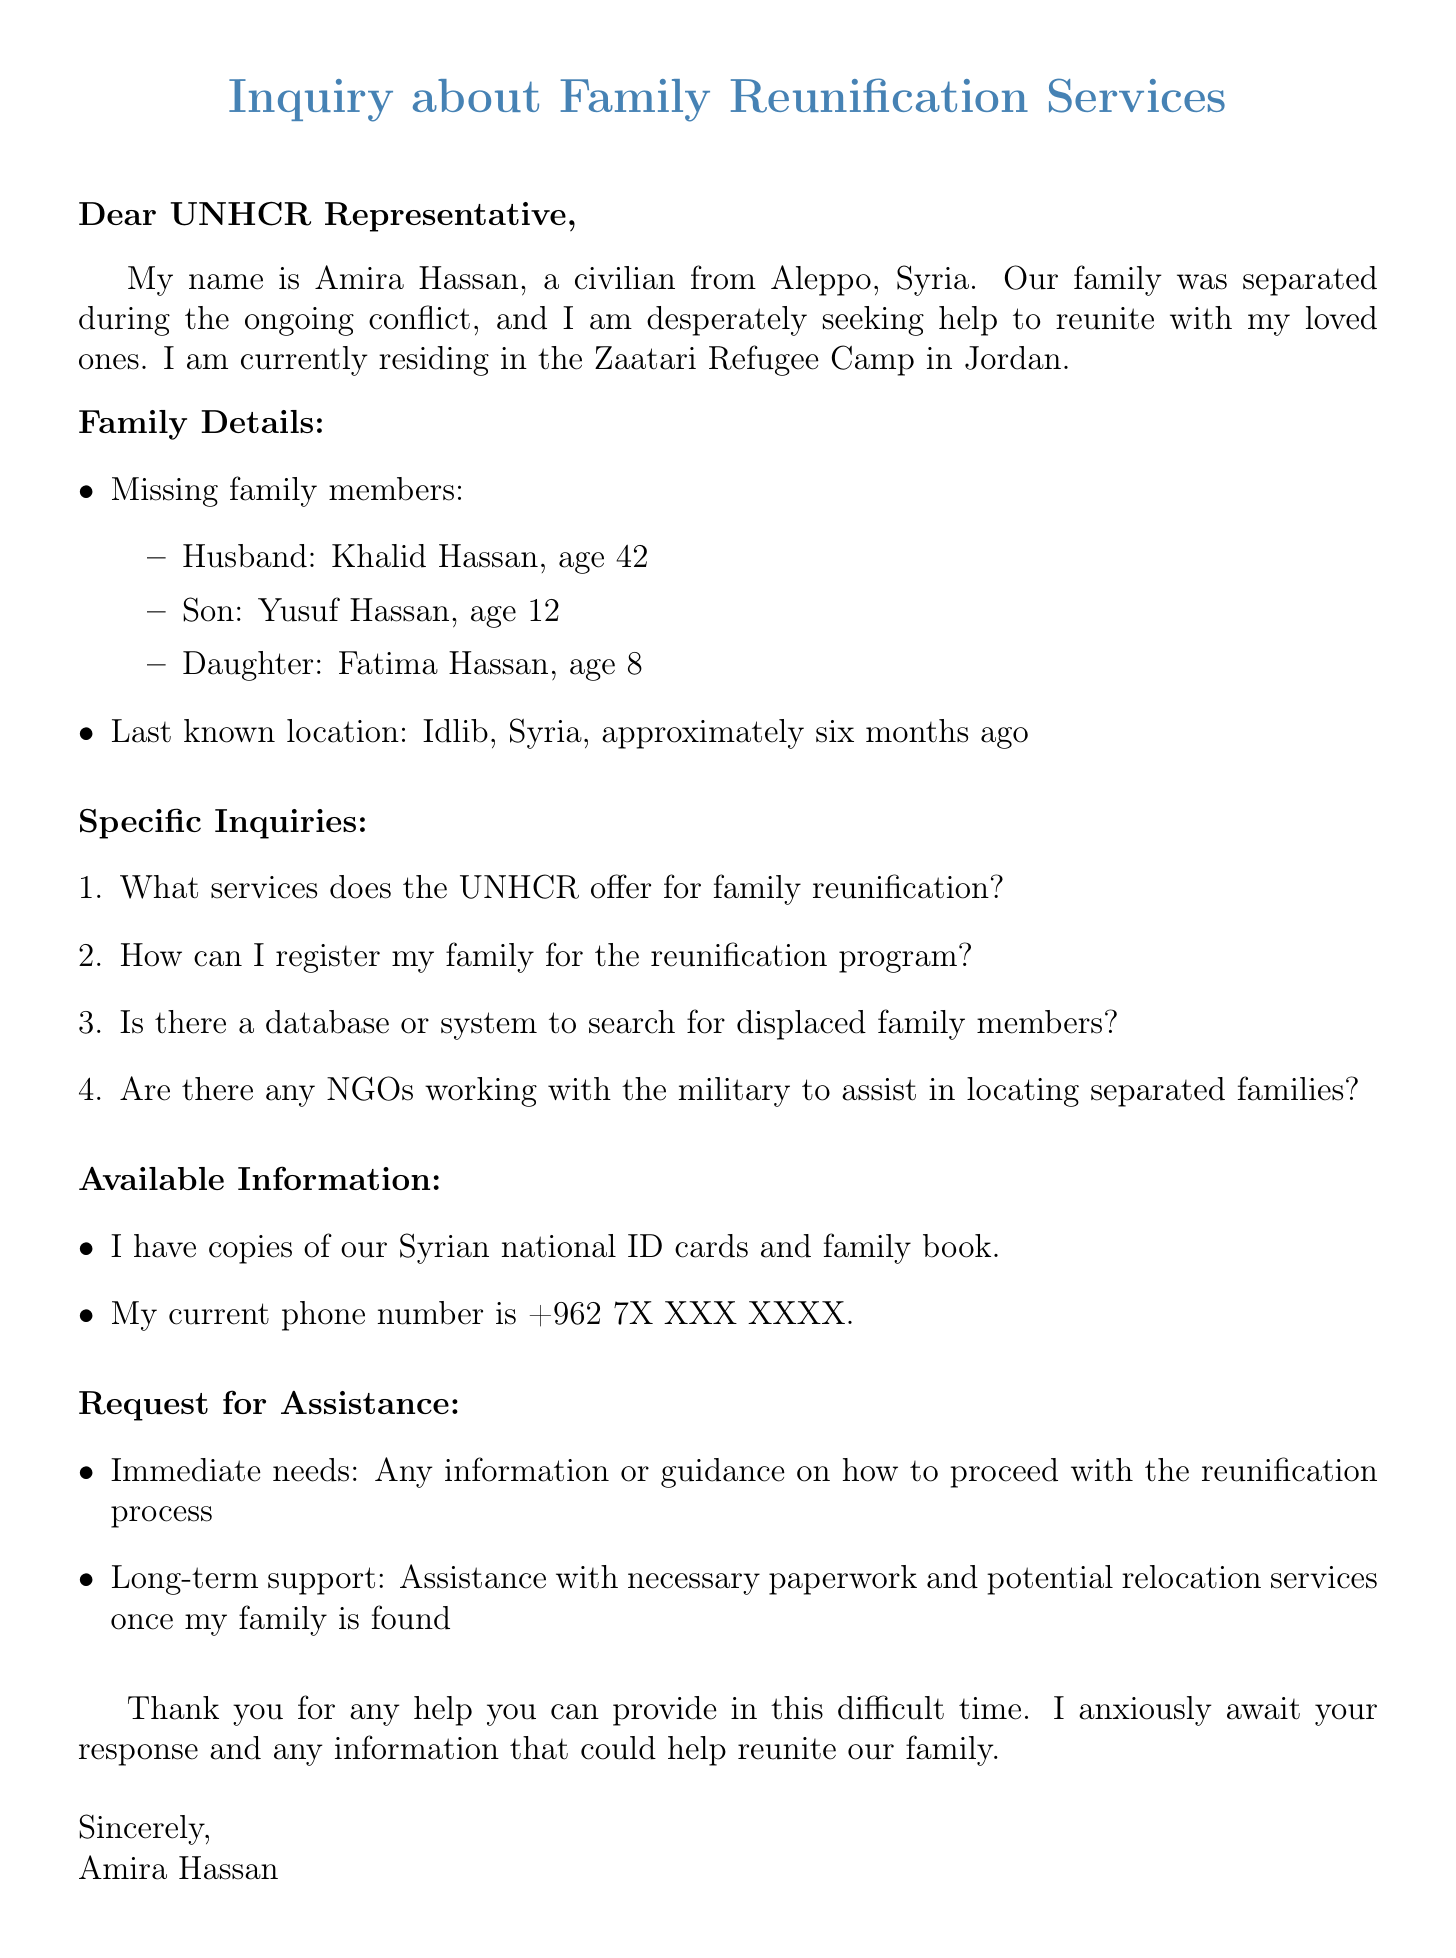What is the name of the person inquiring about family reunification services? The document specifies that the person inquiring is Amira Hassan.
Answer: Amira Hassan How many family members are missing? The document lists three missing family members: Khalid, Yusuf, and Fatima.
Answer: three What is the age of the son? The document states that the son, Yusuf Hassan, is 12 years old.
Answer: 12 Where was the family last seen? The last known location of the missing family members is specified as Idlib, Syria.
Answer: Idlib, Syria What services is Amira seeking information about? The inquiry specifically mentions seeking services for family reunification.
Answer: family reunification What is Amira's current location? The document indicates that Amira is currently residing in the Zaatari Refugee Camp in Jordan.
Answer: Zaatari Refugee Camp in Jordan What type of identification does Amira possess? The document mentions that Amira has copies of Syrian national ID cards and family book.
Answer: Syrian national ID cards and family book What specific assistance is Amira requesting? Amira is requesting guidance on the reunification process and assistance with paperwork.
Answer: guidance on the reunification process and assistance with paperwork What urgency does Amira express in her inquiry? The closing remarks indicate that Amira is anxiously awaiting a response.
Answer: anxiously awaiting a response 